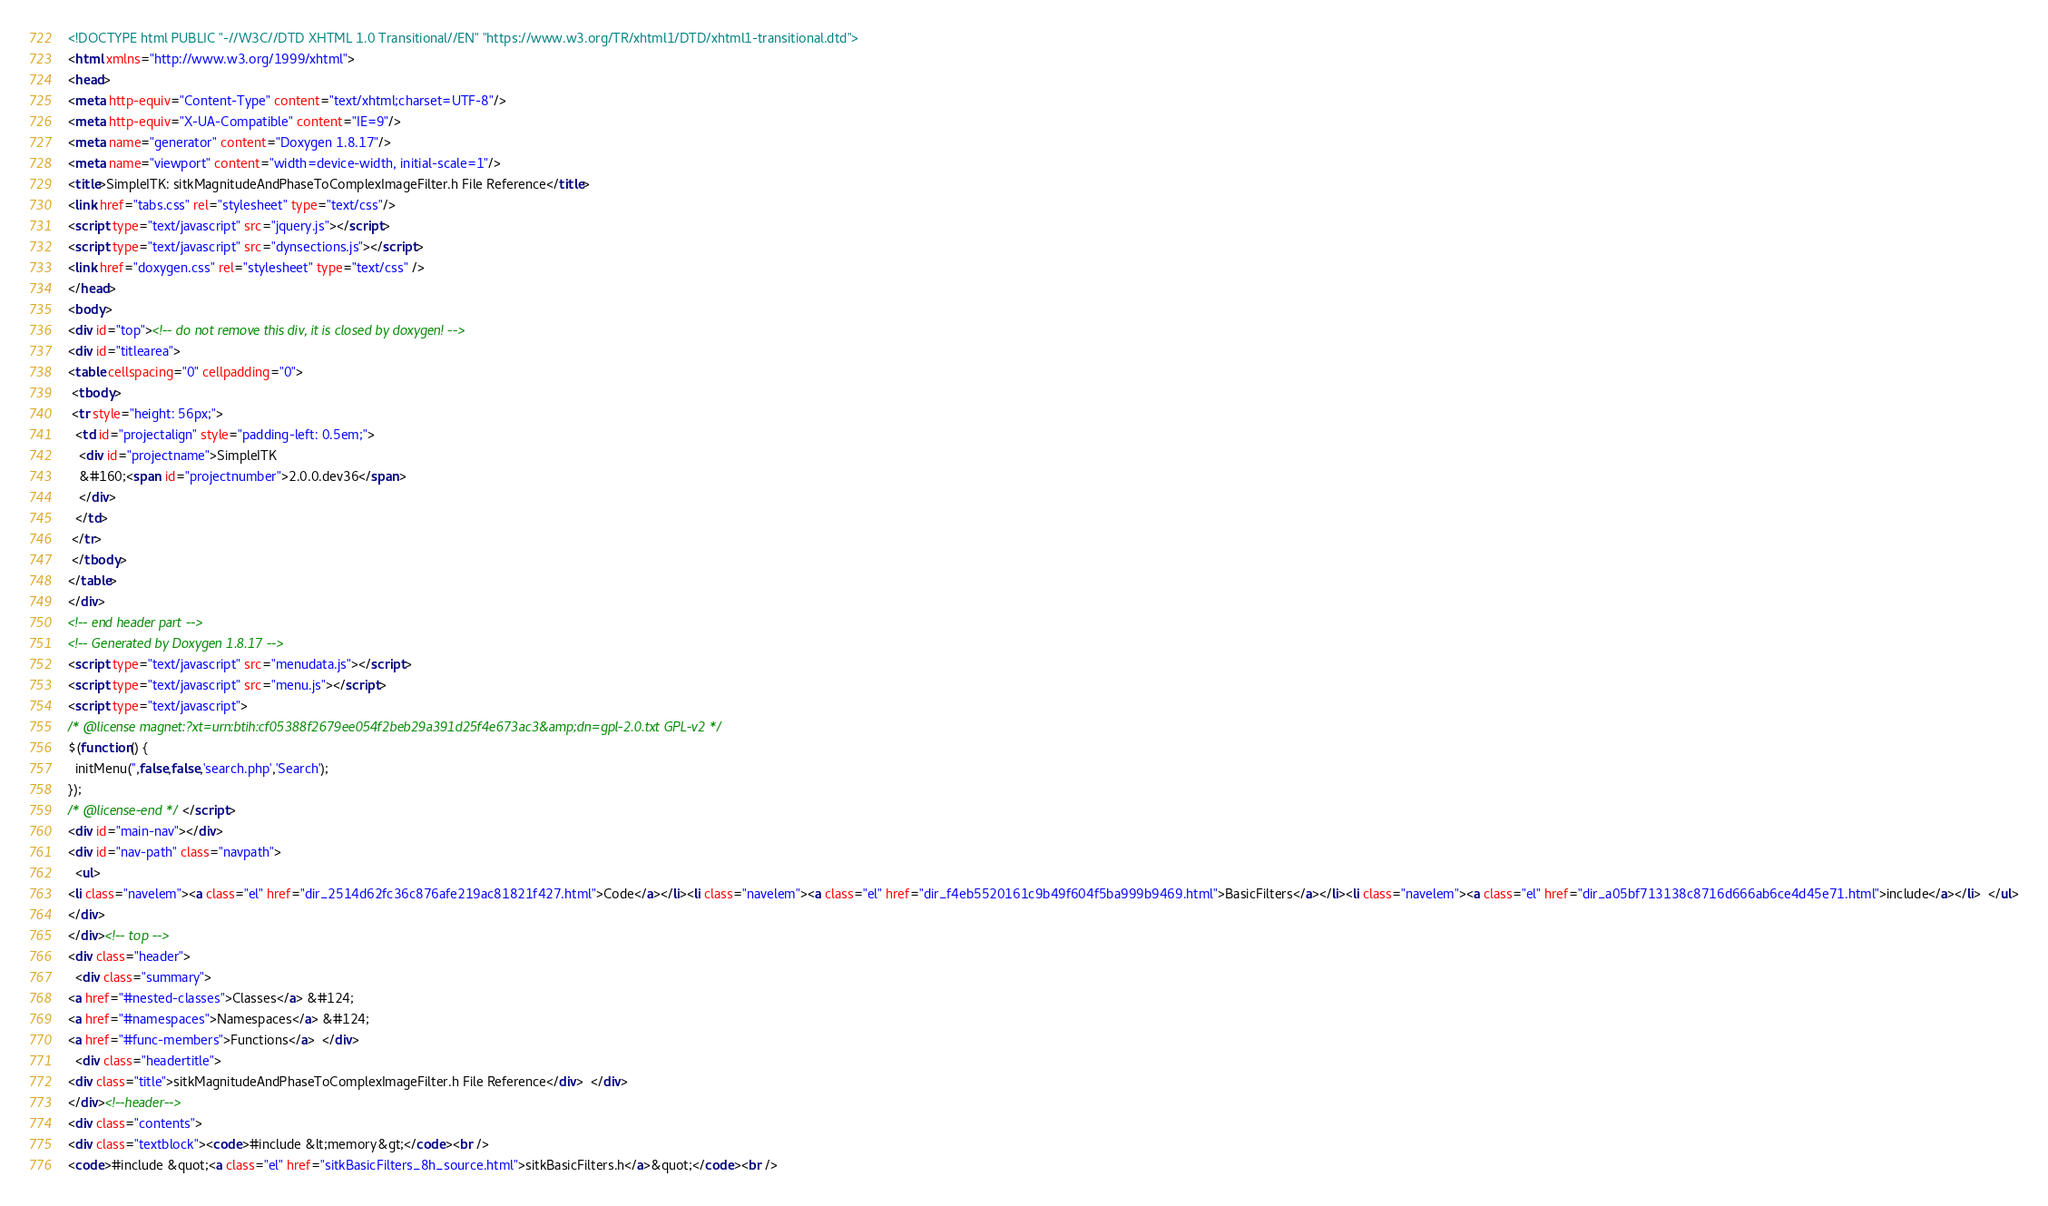<code> <loc_0><loc_0><loc_500><loc_500><_HTML_><!DOCTYPE html PUBLIC "-//W3C//DTD XHTML 1.0 Transitional//EN" "https://www.w3.org/TR/xhtml1/DTD/xhtml1-transitional.dtd">
<html xmlns="http://www.w3.org/1999/xhtml">
<head>
<meta http-equiv="Content-Type" content="text/xhtml;charset=UTF-8"/>
<meta http-equiv="X-UA-Compatible" content="IE=9"/>
<meta name="generator" content="Doxygen 1.8.17"/>
<meta name="viewport" content="width=device-width, initial-scale=1"/>
<title>SimpleITK: sitkMagnitudeAndPhaseToComplexImageFilter.h File Reference</title>
<link href="tabs.css" rel="stylesheet" type="text/css"/>
<script type="text/javascript" src="jquery.js"></script>
<script type="text/javascript" src="dynsections.js"></script>
<link href="doxygen.css" rel="stylesheet" type="text/css" />
</head>
<body>
<div id="top"><!-- do not remove this div, it is closed by doxygen! -->
<div id="titlearea">
<table cellspacing="0" cellpadding="0">
 <tbody>
 <tr style="height: 56px;">
  <td id="projectalign" style="padding-left: 0.5em;">
   <div id="projectname">SimpleITK
   &#160;<span id="projectnumber">2.0.0.dev36</span>
   </div>
  </td>
 </tr>
 </tbody>
</table>
</div>
<!-- end header part -->
<!-- Generated by Doxygen 1.8.17 -->
<script type="text/javascript" src="menudata.js"></script>
<script type="text/javascript" src="menu.js"></script>
<script type="text/javascript">
/* @license magnet:?xt=urn:btih:cf05388f2679ee054f2beb29a391d25f4e673ac3&amp;dn=gpl-2.0.txt GPL-v2 */
$(function() {
  initMenu('',false,false,'search.php','Search');
});
/* @license-end */</script>
<div id="main-nav"></div>
<div id="nav-path" class="navpath">
  <ul>
<li class="navelem"><a class="el" href="dir_2514d62fc36c876afe219ac81821f427.html">Code</a></li><li class="navelem"><a class="el" href="dir_f4eb5520161c9b49f604f5ba999b9469.html">BasicFilters</a></li><li class="navelem"><a class="el" href="dir_a05bf713138c8716d666ab6ce4d45e71.html">include</a></li>  </ul>
</div>
</div><!-- top -->
<div class="header">
  <div class="summary">
<a href="#nested-classes">Classes</a> &#124;
<a href="#namespaces">Namespaces</a> &#124;
<a href="#func-members">Functions</a>  </div>
  <div class="headertitle">
<div class="title">sitkMagnitudeAndPhaseToComplexImageFilter.h File Reference</div>  </div>
</div><!--header-->
<div class="contents">
<div class="textblock"><code>#include &lt;memory&gt;</code><br />
<code>#include &quot;<a class="el" href="sitkBasicFilters_8h_source.html">sitkBasicFilters.h</a>&quot;</code><br /></code> 